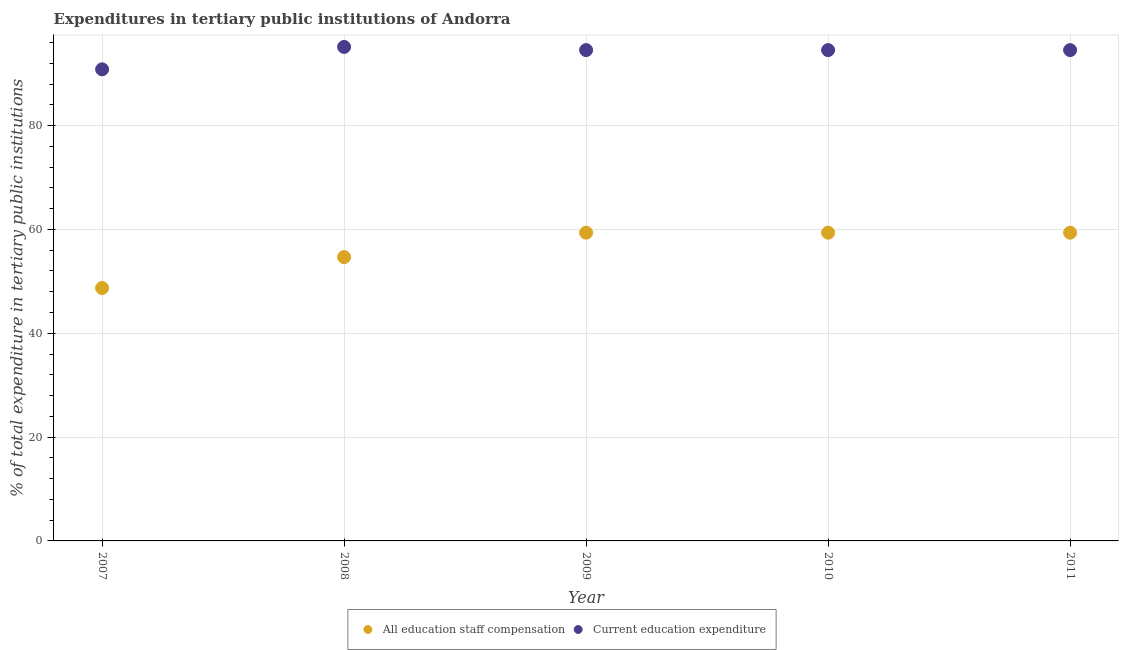What is the expenditure in staff compensation in 2008?
Keep it short and to the point. 54.67. Across all years, what is the maximum expenditure in staff compensation?
Offer a very short reply. 59.38. Across all years, what is the minimum expenditure in staff compensation?
Provide a short and direct response. 48.72. What is the total expenditure in education in the graph?
Make the answer very short. 469.66. What is the difference between the expenditure in education in 2007 and that in 2009?
Make the answer very short. -3.71. What is the difference between the expenditure in staff compensation in 2010 and the expenditure in education in 2009?
Offer a very short reply. -35.17. What is the average expenditure in staff compensation per year?
Provide a short and direct response. 56.31. In the year 2011, what is the difference between the expenditure in staff compensation and expenditure in education?
Provide a short and direct response. -35.17. In how many years, is the expenditure in education greater than 52 %?
Your answer should be very brief. 5. What is the ratio of the expenditure in staff compensation in 2007 to that in 2009?
Keep it short and to the point. 0.82. Is the expenditure in education in 2010 less than that in 2011?
Your answer should be very brief. No. What is the difference between the highest and the second highest expenditure in education?
Your answer should be compact. 0.61. What is the difference between the highest and the lowest expenditure in education?
Your response must be concise. 4.32. Does the expenditure in education monotonically increase over the years?
Your answer should be very brief. No. Is the expenditure in staff compensation strictly less than the expenditure in education over the years?
Offer a very short reply. Yes. How many dotlines are there?
Provide a succinct answer. 2. Are the values on the major ticks of Y-axis written in scientific E-notation?
Your answer should be very brief. No. Does the graph contain grids?
Make the answer very short. Yes. Where does the legend appear in the graph?
Provide a succinct answer. Bottom center. How many legend labels are there?
Make the answer very short. 2. What is the title of the graph?
Make the answer very short. Expenditures in tertiary public institutions of Andorra. Does "Netherlands" appear as one of the legend labels in the graph?
Offer a terse response. No. What is the label or title of the X-axis?
Provide a succinct answer. Year. What is the label or title of the Y-axis?
Keep it short and to the point. % of total expenditure in tertiary public institutions. What is the % of total expenditure in tertiary public institutions of All education staff compensation in 2007?
Provide a succinct answer. 48.72. What is the % of total expenditure in tertiary public institutions of Current education expenditure in 2007?
Your answer should be very brief. 90.84. What is the % of total expenditure in tertiary public institutions in All education staff compensation in 2008?
Ensure brevity in your answer.  54.67. What is the % of total expenditure in tertiary public institutions in Current education expenditure in 2008?
Give a very brief answer. 95.16. What is the % of total expenditure in tertiary public institutions of All education staff compensation in 2009?
Ensure brevity in your answer.  59.38. What is the % of total expenditure in tertiary public institutions in Current education expenditure in 2009?
Keep it short and to the point. 94.55. What is the % of total expenditure in tertiary public institutions of All education staff compensation in 2010?
Your answer should be compact. 59.38. What is the % of total expenditure in tertiary public institutions of Current education expenditure in 2010?
Make the answer very short. 94.55. What is the % of total expenditure in tertiary public institutions in All education staff compensation in 2011?
Your response must be concise. 59.38. What is the % of total expenditure in tertiary public institutions in Current education expenditure in 2011?
Provide a succinct answer. 94.55. Across all years, what is the maximum % of total expenditure in tertiary public institutions of All education staff compensation?
Provide a short and direct response. 59.38. Across all years, what is the maximum % of total expenditure in tertiary public institutions of Current education expenditure?
Give a very brief answer. 95.16. Across all years, what is the minimum % of total expenditure in tertiary public institutions of All education staff compensation?
Make the answer very short. 48.72. Across all years, what is the minimum % of total expenditure in tertiary public institutions of Current education expenditure?
Ensure brevity in your answer.  90.84. What is the total % of total expenditure in tertiary public institutions of All education staff compensation in the graph?
Your answer should be very brief. 281.53. What is the total % of total expenditure in tertiary public institutions of Current education expenditure in the graph?
Ensure brevity in your answer.  469.66. What is the difference between the % of total expenditure in tertiary public institutions of All education staff compensation in 2007 and that in 2008?
Your answer should be very brief. -5.95. What is the difference between the % of total expenditure in tertiary public institutions in Current education expenditure in 2007 and that in 2008?
Offer a very short reply. -4.32. What is the difference between the % of total expenditure in tertiary public institutions in All education staff compensation in 2007 and that in 2009?
Offer a very short reply. -10.66. What is the difference between the % of total expenditure in tertiary public institutions in Current education expenditure in 2007 and that in 2009?
Make the answer very short. -3.71. What is the difference between the % of total expenditure in tertiary public institutions in All education staff compensation in 2007 and that in 2010?
Your answer should be compact. -10.66. What is the difference between the % of total expenditure in tertiary public institutions of Current education expenditure in 2007 and that in 2010?
Provide a succinct answer. -3.71. What is the difference between the % of total expenditure in tertiary public institutions in All education staff compensation in 2007 and that in 2011?
Offer a terse response. -10.66. What is the difference between the % of total expenditure in tertiary public institutions of Current education expenditure in 2007 and that in 2011?
Provide a succinct answer. -3.71. What is the difference between the % of total expenditure in tertiary public institutions of All education staff compensation in 2008 and that in 2009?
Your answer should be very brief. -4.71. What is the difference between the % of total expenditure in tertiary public institutions of Current education expenditure in 2008 and that in 2009?
Provide a short and direct response. 0.61. What is the difference between the % of total expenditure in tertiary public institutions in All education staff compensation in 2008 and that in 2010?
Offer a very short reply. -4.71. What is the difference between the % of total expenditure in tertiary public institutions in Current education expenditure in 2008 and that in 2010?
Provide a short and direct response. 0.61. What is the difference between the % of total expenditure in tertiary public institutions of All education staff compensation in 2008 and that in 2011?
Make the answer very short. -4.71. What is the difference between the % of total expenditure in tertiary public institutions of Current education expenditure in 2008 and that in 2011?
Your answer should be compact. 0.61. What is the difference between the % of total expenditure in tertiary public institutions in All education staff compensation in 2010 and that in 2011?
Offer a terse response. 0. What is the difference between the % of total expenditure in tertiary public institutions of Current education expenditure in 2010 and that in 2011?
Provide a short and direct response. 0. What is the difference between the % of total expenditure in tertiary public institutions of All education staff compensation in 2007 and the % of total expenditure in tertiary public institutions of Current education expenditure in 2008?
Your answer should be compact. -46.44. What is the difference between the % of total expenditure in tertiary public institutions of All education staff compensation in 2007 and the % of total expenditure in tertiary public institutions of Current education expenditure in 2009?
Offer a terse response. -45.83. What is the difference between the % of total expenditure in tertiary public institutions in All education staff compensation in 2007 and the % of total expenditure in tertiary public institutions in Current education expenditure in 2010?
Ensure brevity in your answer.  -45.83. What is the difference between the % of total expenditure in tertiary public institutions in All education staff compensation in 2007 and the % of total expenditure in tertiary public institutions in Current education expenditure in 2011?
Your answer should be compact. -45.83. What is the difference between the % of total expenditure in tertiary public institutions in All education staff compensation in 2008 and the % of total expenditure in tertiary public institutions in Current education expenditure in 2009?
Your answer should be very brief. -39.88. What is the difference between the % of total expenditure in tertiary public institutions in All education staff compensation in 2008 and the % of total expenditure in tertiary public institutions in Current education expenditure in 2010?
Give a very brief answer. -39.88. What is the difference between the % of total expenditure in tertiary public institutions of All education staff compensation in 2008 and the % of total expenditure in tertiary public institutions of Current education expenditure in 2011?
Your answer should be very brief. -39.88. What is the difference between the % of total expenditure in tertiary public institutions of All education staff compensation in 2009 and the % of total expenditure in tertiary public institutions of Current education expenditure in 2010?
Offer a terse response. -35.17. What is the difference between the % of total expenditure in tertiary public institutions in All education staff compensation in 2009 and the % of total expenditure in tertiary public institutions in Current education expenditure in 2011?
Make the answer very short. -35.17. What is the difference between the % of total expenditure in tertiary public institutions of All education staff compensation in 2010 and the % of total expenditure in tertiary public institutions of Current education expenditure in 2011?
Give a very brief answer. -35.17. What is the average % of total expenditure in tertiary public institutions in All education staff compensation per year?
Ensure brevity in your answer.  56.31. What is the average % of total expenditure in tertiary public institutions of Current education expenditure per year?
Make the answer very short. 93.93. In the year 2007, what is the difference between the % of total expenditure in tertiary public institutions of All education staff compensation and % of total expenditure in tertiary public institutions of Current education expenditure?
Provide a short and direct response. -42.12. In the year 2008, what is the difference between the % of total expenditure in tertiary public institutions in All education staff compensation and % of total expenditure in tertiary public institutions in Current education expenditure?
Your response must be concise. -40.49. In the year 2009, what is the difference between the % of total expenditure in tertiary public institutions in All education staff compensation and % of total expenditure in tertiary public institutions in Current education expenditure?
Provide a short and direct response. -35.17. In the year 2010, what is the difference between the % of total expenditure in tertiary public institutions of All education staff compensation and % of total expenditure in tertiary public institutions of Current education expenditure?
Provide a short and direct response. -35.17. In the year 2011, what is the difference between the % of total expenditure in tertiary public institutions of All education staff compensation and % of total expenditure in tertiary public institutions of Current education expenditure?
Your answer should be compact. -35.17. What is the ratio of the % of total expenditure in tertiary public institutions of All education staff compensation in 2007 to that in 2008?
Provide a short and direct response. 0.89. What is the ratio of the % of total expenditure in tertiary public institutions in Current education expenditure in 2007 to that in 2008?
Give a very brief answer. 0.95. What is the ratio of the % of total expenditure in tertiary public institutions of All education staff compensation in 2007 to that in 2009?
Give a very brief answer. 0.82. What is the ratio of the % of total expenditure in tertiary public institutions in Current education expenditure in 2007 to that in 2009?
Provide a succinct answer. 0.96. What is the ratio of the % of total expenditure in tertiary public institutions of All education staff compensation in 2007 to that in 2010?
Provide a succinct answer. 0.82. What is the ratio of the % of total expenditure in tertiary public institutions of Current education expenditure in 2007 to that in 2010?
Offer a very short reply. 0.96. What is the ratio of the % of total expenditure in tertiary public institutions of All education staff compensation in 2007 to that in 2011?
Ensure brevity in your answer.  0.82. What is the ratio of the % of total expenditure in tertiary public institutions in Current education expenditure in 2007 to that in 2011?
Give a very brief answer. 0.96. What is the ratio of the % of total expenditure in tertiary public institutions in All education staff compensation in 2008 to that in 2009?
Your answer should be very brief. 0.92. What is the ratio of the % of total expenditure in tertiary public institutions of All education staff compensation in 2008 to that in 2010?
Give a very brief answer. 0.92. What is the ratio of the % of total expenditure in tertiary public institutions in Current education expenditure in 2008 to that in 2010?
Offer a terse response. 1.01. What is the ratio of the % of total expenditure in tertiary public institutions of All education staff compensation in 2008 to that in 2011?
Give a very brief answer. 0.92. What is the ratio of the % of total expenditure in tertiary public institutions in Current education expenditure in 2008 to that in 2011?
Your answer should be compact. 1.01. What is the ratio of the % of total expenditure in tertiary public institutions in All education staff compensation in 2009 to that in 2011?
Your answer should be very brief. 1. What is the ratio of the % of total expenditure in tertiary public institutions of Current education expenditure in 2010 to that in 2011?
Your answer should be very brief. 1. What is the difference between the highest and the second highest % of total expenditure in tertiary public institutions in Current education expenditure?
Your answer should be very brief. 0.61. What is the difference between the highest and the lowest % of total expenditure in tertiary public institutions in All education staff compensation?
Give a very brief answer. 10.66. What is the difference between the highest and the lowest % of total expenditure in tertiary public institutions of Current education expenditure?
Give a very brief answer. 4.32. 